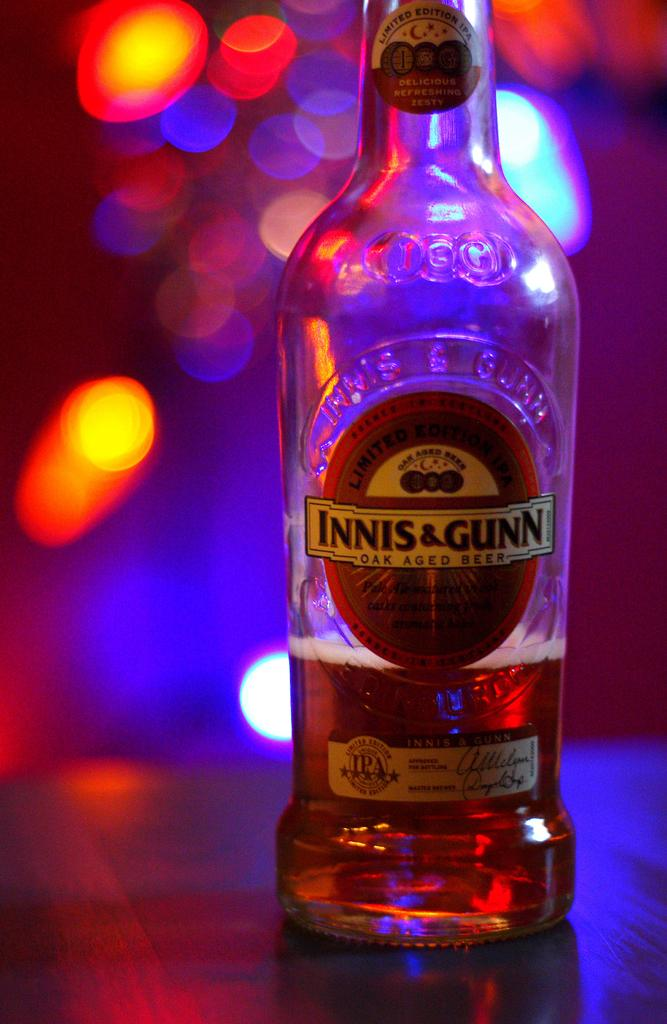<image>
Create a compact narrative representing the image presented. An almost empty bottle of Innis & Gunn oak aged beer. 